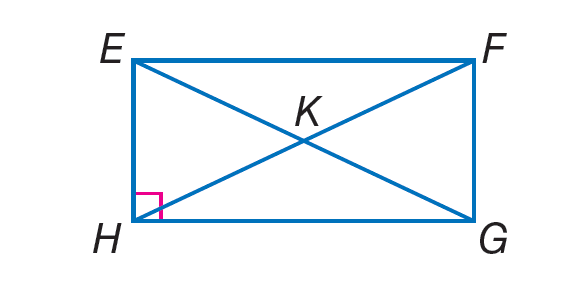Answer the mathemtical geometry problem and directly provide the correct option letter.
Question: Quadrilateral E F G H is a rectangle. Find m \angle H E F + m \angle E F G.
Choices: A: 33 B: 57 C: 70 D: 180 D 